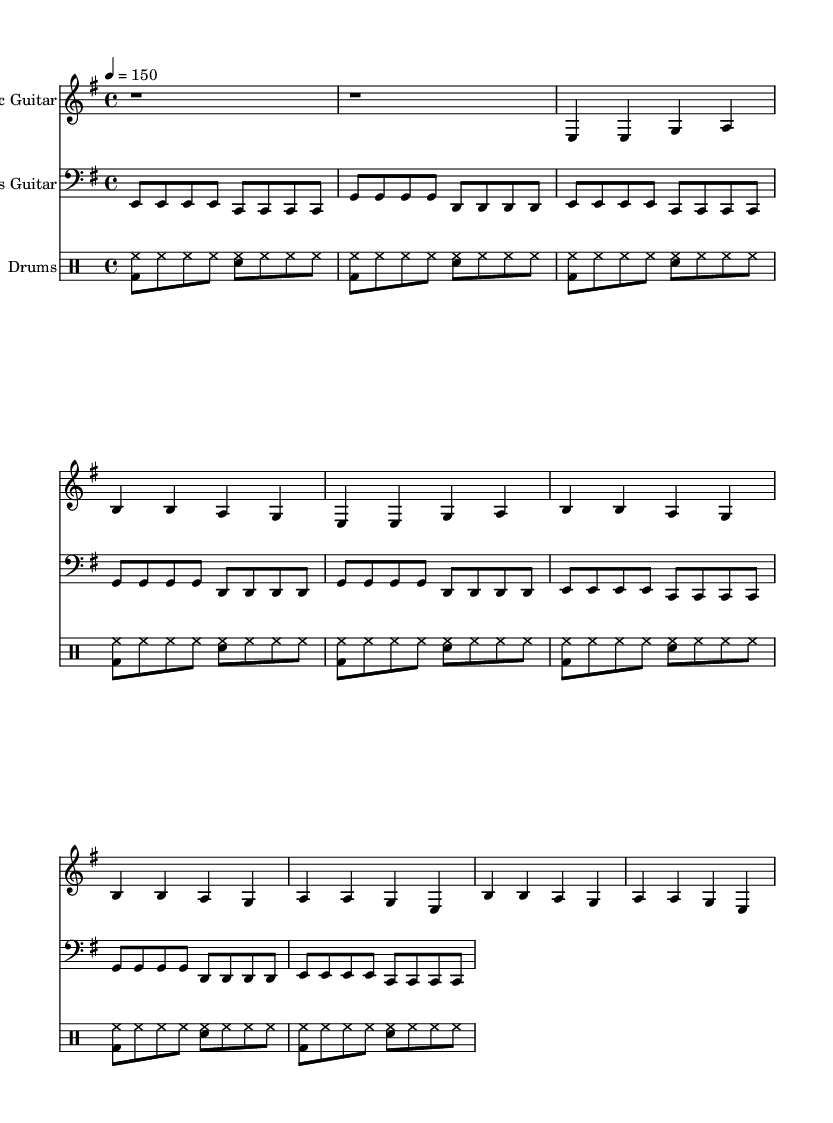What is the key signature of this music? The key signature is E minor, which contains one sharp (F#). This can be determined by looking at the key signature indicator at the beginning of the treble and bass staves.
Answer: E minor What is the time signature? The time signature shown in the music is 4/4, which indicates there are four beats in each measure and the quarter note gets one beat. This is found at the beginning of the score in both the treble and bass staves.
Answer: 4/4 What is the tempo marking? The tempo marking is 150 beats per minute, which indicates the speed of the music. This is indicated at the beginning of the score.
Answer: 150 How many measures are in the verse section? The verse section contains four measures. This is determined by counting the measures in the section labeled "Verse" in the notation provided.
Answer: Four What instruments are used in this score? The score includes Electric Guitar, Bass Guitar, and Drums, as indicated by the staff names above each section of music.
Answer: Electric Guitar, Bass Guitar, Drums What is the primary theme of the lyrics? The primary theme of the lyrics focuses on data analysis and targeted marketing campaigns. This is inferred from the content of the verse and chorus lyrics.
Answer: Data analysis How does the chorus relate to the verse in terms of musical structure? The chorus follows a similar musical structure to the verse but emphasizes a different message and rhythm. It uses the same time signature and shares some melodic elements, but the lyrics express a more confident and rebellious tone.
Answer: Similar structure, different message 